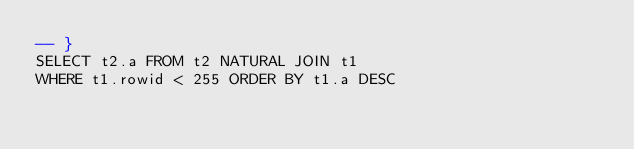<code> <loc_0><loc_0><loc_500><loc_500><_SQL_>-- }
SELECT t2.a FROM t2 NATURAL JOIN t1
WHERE t1.rowid < 255 ORDER BY t1.a DESC</code> 